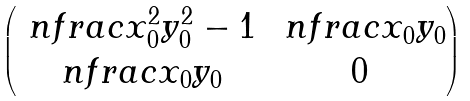Convert formula to latex. <formula><loc_0><loc_0><loc_500><loc_500>\begin{pmatrix} \ n f r a c { x _ { 0 } ^ { 2 } } { y _ { 0 } ^ { 2 } } - 1 & \ n f r a c { x _ { 0 } } { y _ { 0 } } \\ \ n f r a c { x _ { 0 } } { y _ { 0 } } & 0 \end{pmatrix}</formula> 